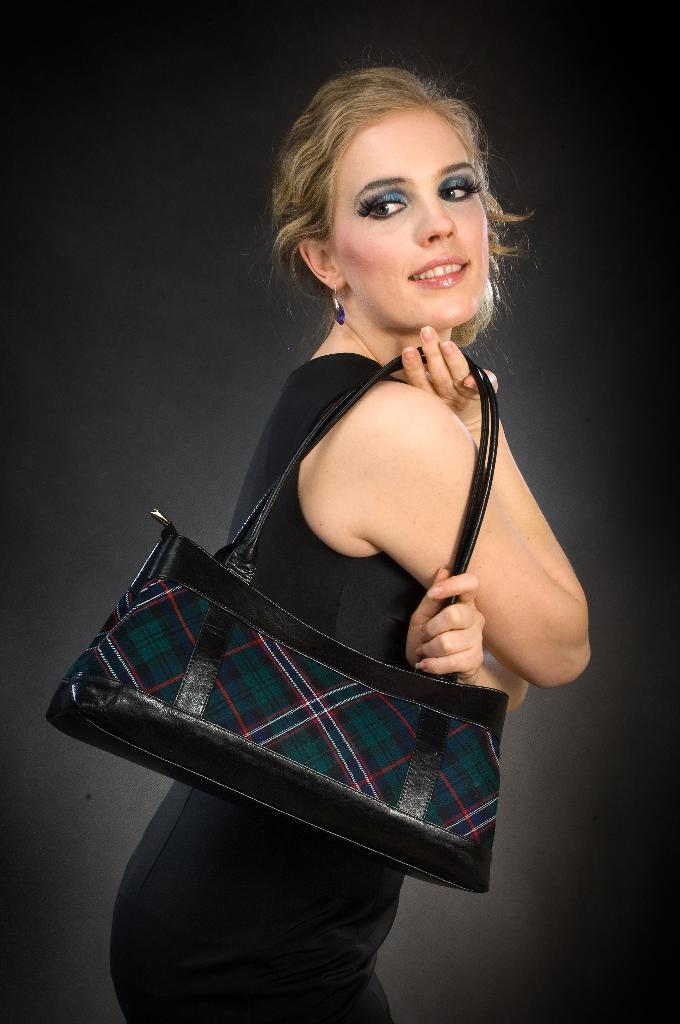Who is present in the image? There is a woman in the image. What is the woman wearing? The woman is wearing a black dress. What accessory is the woman carrying? The woman is carrying a handbag. What can be seen in the background of the image? There is a black wall in the background of the image. What industry does the woman in the image work in? There is no information about the woman's profession or industry in the image. 